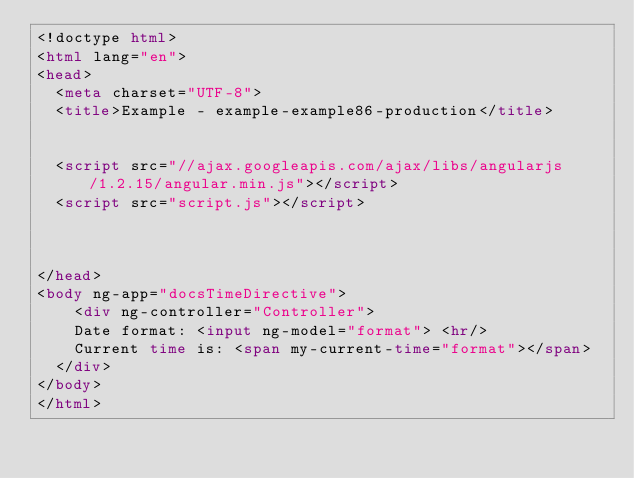Convert code to text. <code><loc_0><loc_0><loc_500><loc_500><_HTML_><!doctype html>
<html lang="en">
<head>
  <meta charset="UTF-8">
  <title>Example - example-example86-production</title>
  

  <script src="//ajax.googleapis.com/ajax/libs/angularjs/1.2.15/angular.min.js"></script>
  <script src="script.js"></script>
  

  
</head>
<body ng-app="docsTimeDirective">
    <div ng-controller="Controller">
    Date format: <input ng-model="format"> <hr/>
    Current time is: <span my-current-time="format"></span>
  </div>
</body>
</html></code> 